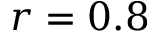<formula> <loc_0><loc_0><loc_500><loc_500>r = 0 . 8</formula> 